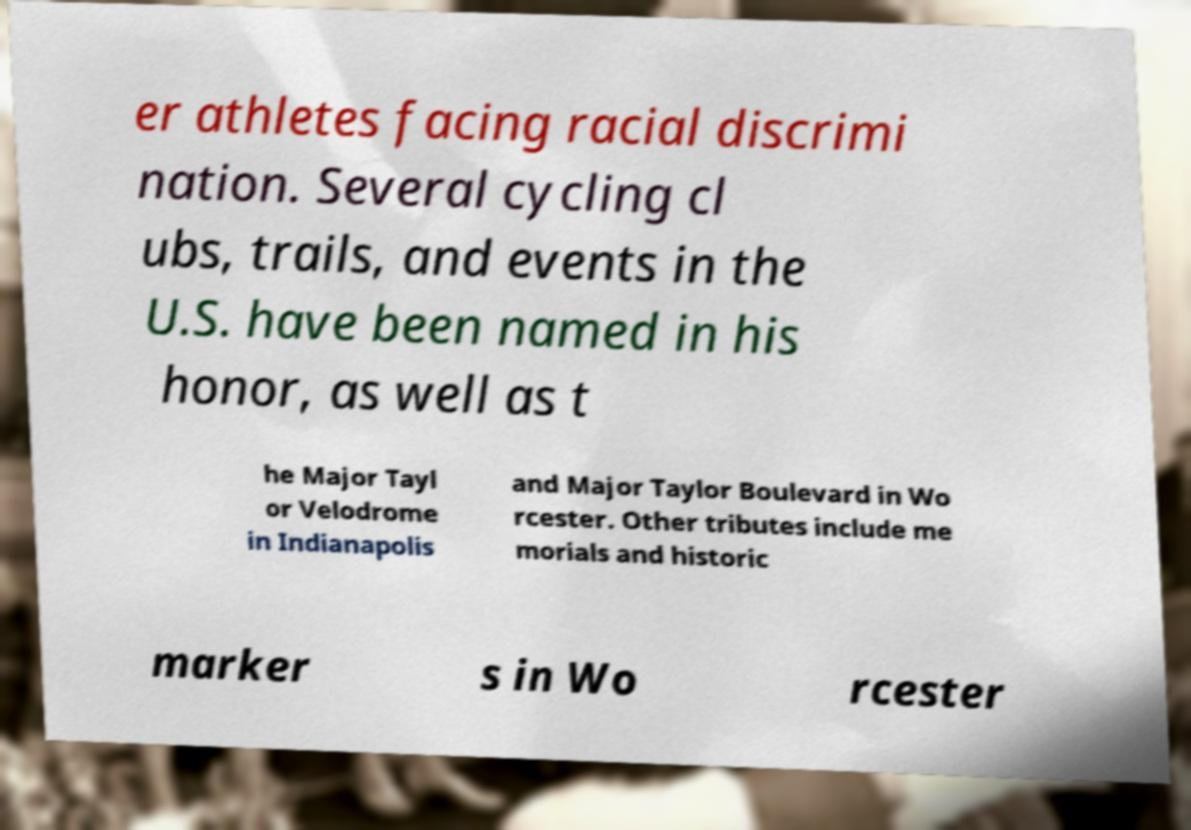Could you assist in decoding the text presented in this image and type it out clearly? er athletes facing racial discrimi nation. Several cycling cl ubs, trails, and events in the U.S. have been named in his honor, as well as t he Major Tayl or Velodrome in Indianapolis and Major Taylor Boulevard in Wo rcester. Other tributes include me morials and historic marker s in Wo rcester 